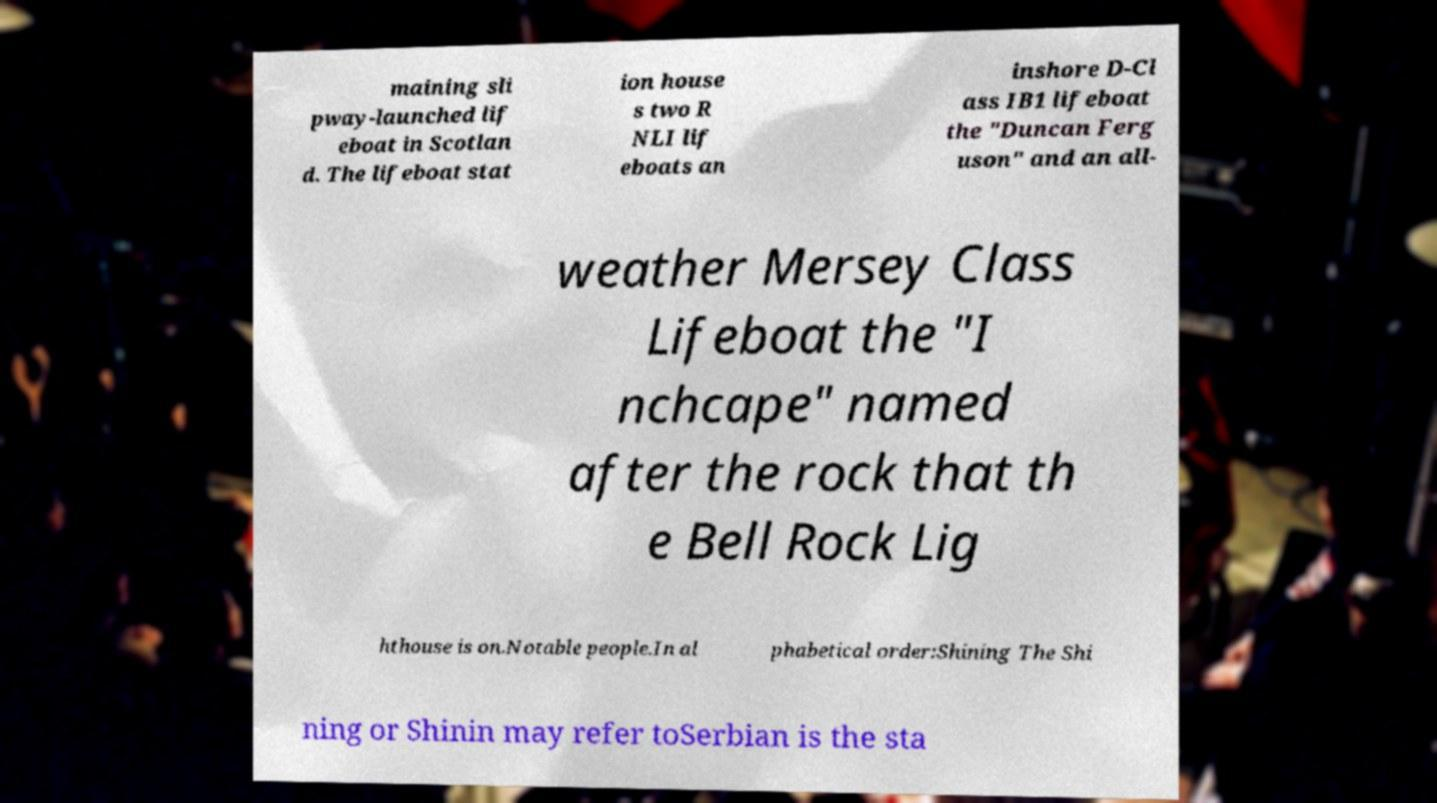Please read and relay the text visible in this image. What does it say? maining sli pway-launched lif eboat in Scotlan d. The lifeboat stat ion house s two R NLI lif eboats an inshore D-Cl ass IB1 lifeboat the "Duncan Ferg uson" and an all- weather Mersey Class Lifeboat the "I nchcape" named after the rock that th e Bell Rock Lig hthouse is on.Notable people.In al phabetical order:Shining The Shi ning or Shinin may refer toSerbian is the sta 